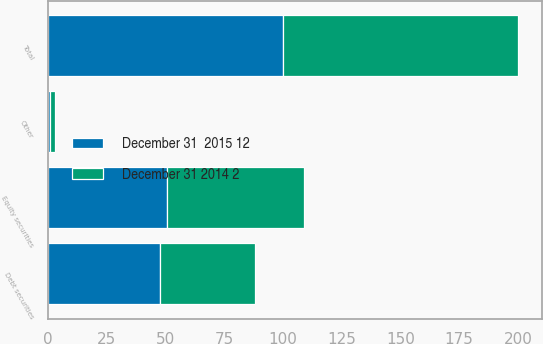Convert chart to OTSL. <chart><loc_0><loc_0><loc_500><loc_500><stacked_bar_chart><ecel><fcel>Equity securities<fcel>Debt securities<fcel>Other<fcel>Total<nl><fcel>December 31 2014 2<fcel>58<fcel>40<fcel>2<fcel>100<nl><fcel>December 31  2015 12<fcel>51<fcel>48<fcel>1<fcel>100<nl></chart> 